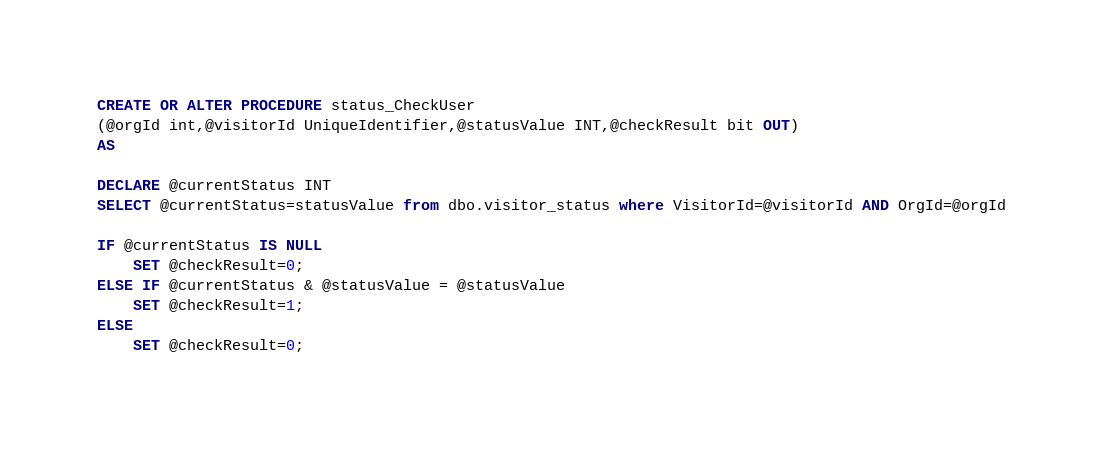<code> <loc_0><loc_0><loc_500><loc_500><_SQL_>CREATE OR ALTER PROCEDURE status_CheckUser
(@orgId int,@visitorId UniqueIdentifier,@statusValue INT,@checkResult bit OUT)
AS

DECLARE @currentStatus INT
SELECT @currentStatus=statusValue from dbo.visitor_status where VisitorId=@visitorId AND OrgId=@orgId

IF @currentStatus IS NULL
    SET @checkResult=0;
ELSE IF @currentStatus & @statusValue = @statusValue
    SET @checkResult=1;
ELSE
    SET @checkResult=0;</code> 